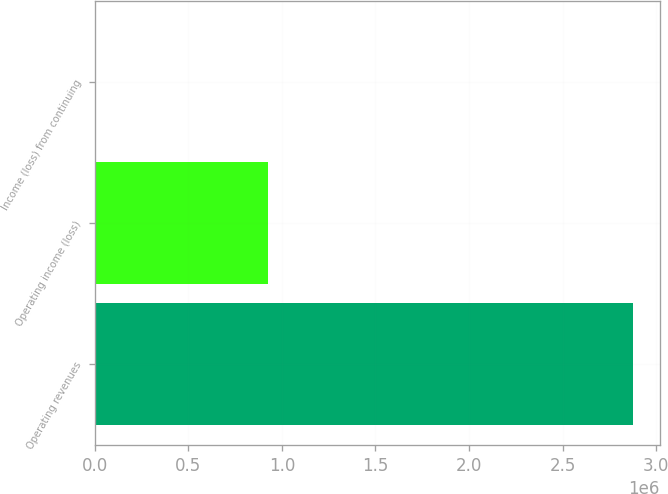<chart> <loc_0><loc_0><loc_500><loc_500><bar_chart><fcel>Operating revenues<fcel>Operating income (loss)<fcel>Income (loss) from continuing<nl><fcel>2.87689e+06<fcel>924973<fcel>2.11<nl></chart> 